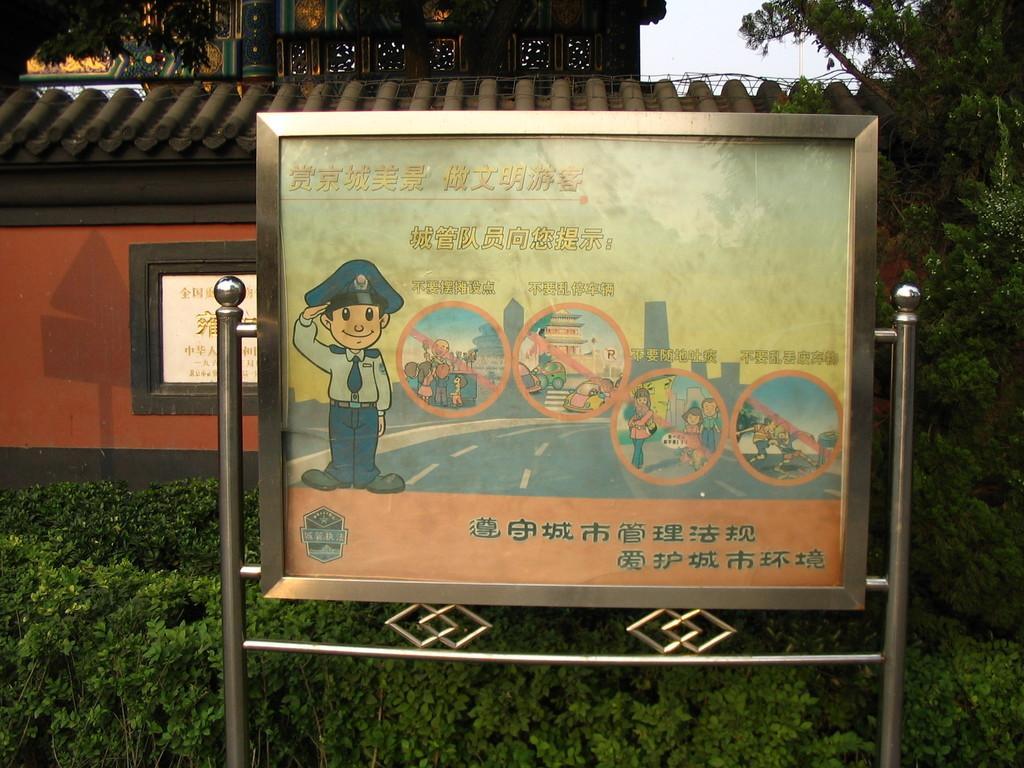How would you summarize this image in a sentence or two? In this image I can see few metal poles and a board attached to it. I can see few trees which are green in color, an orange colored wall and a building. In the background I can see the sky. 